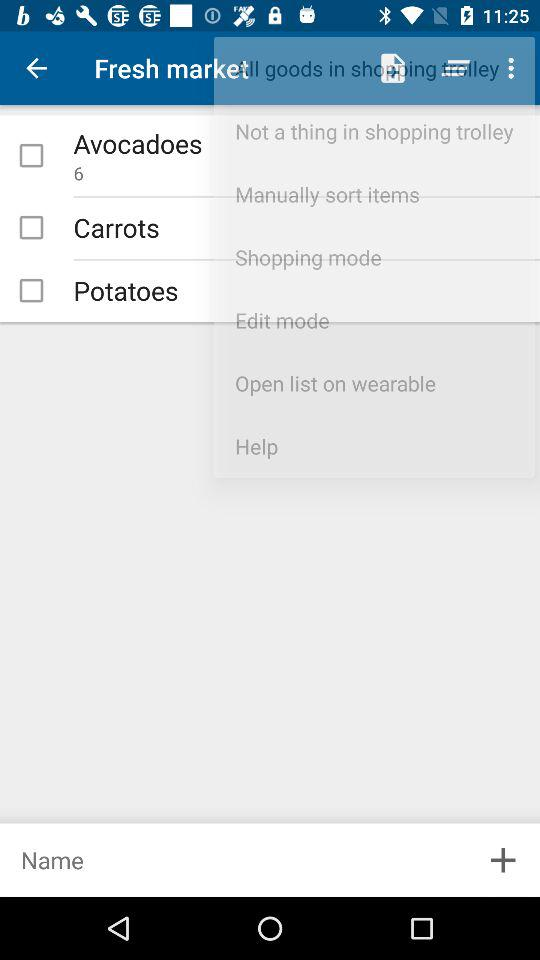How many avocadoes are there? There are 6 avocadoes. 